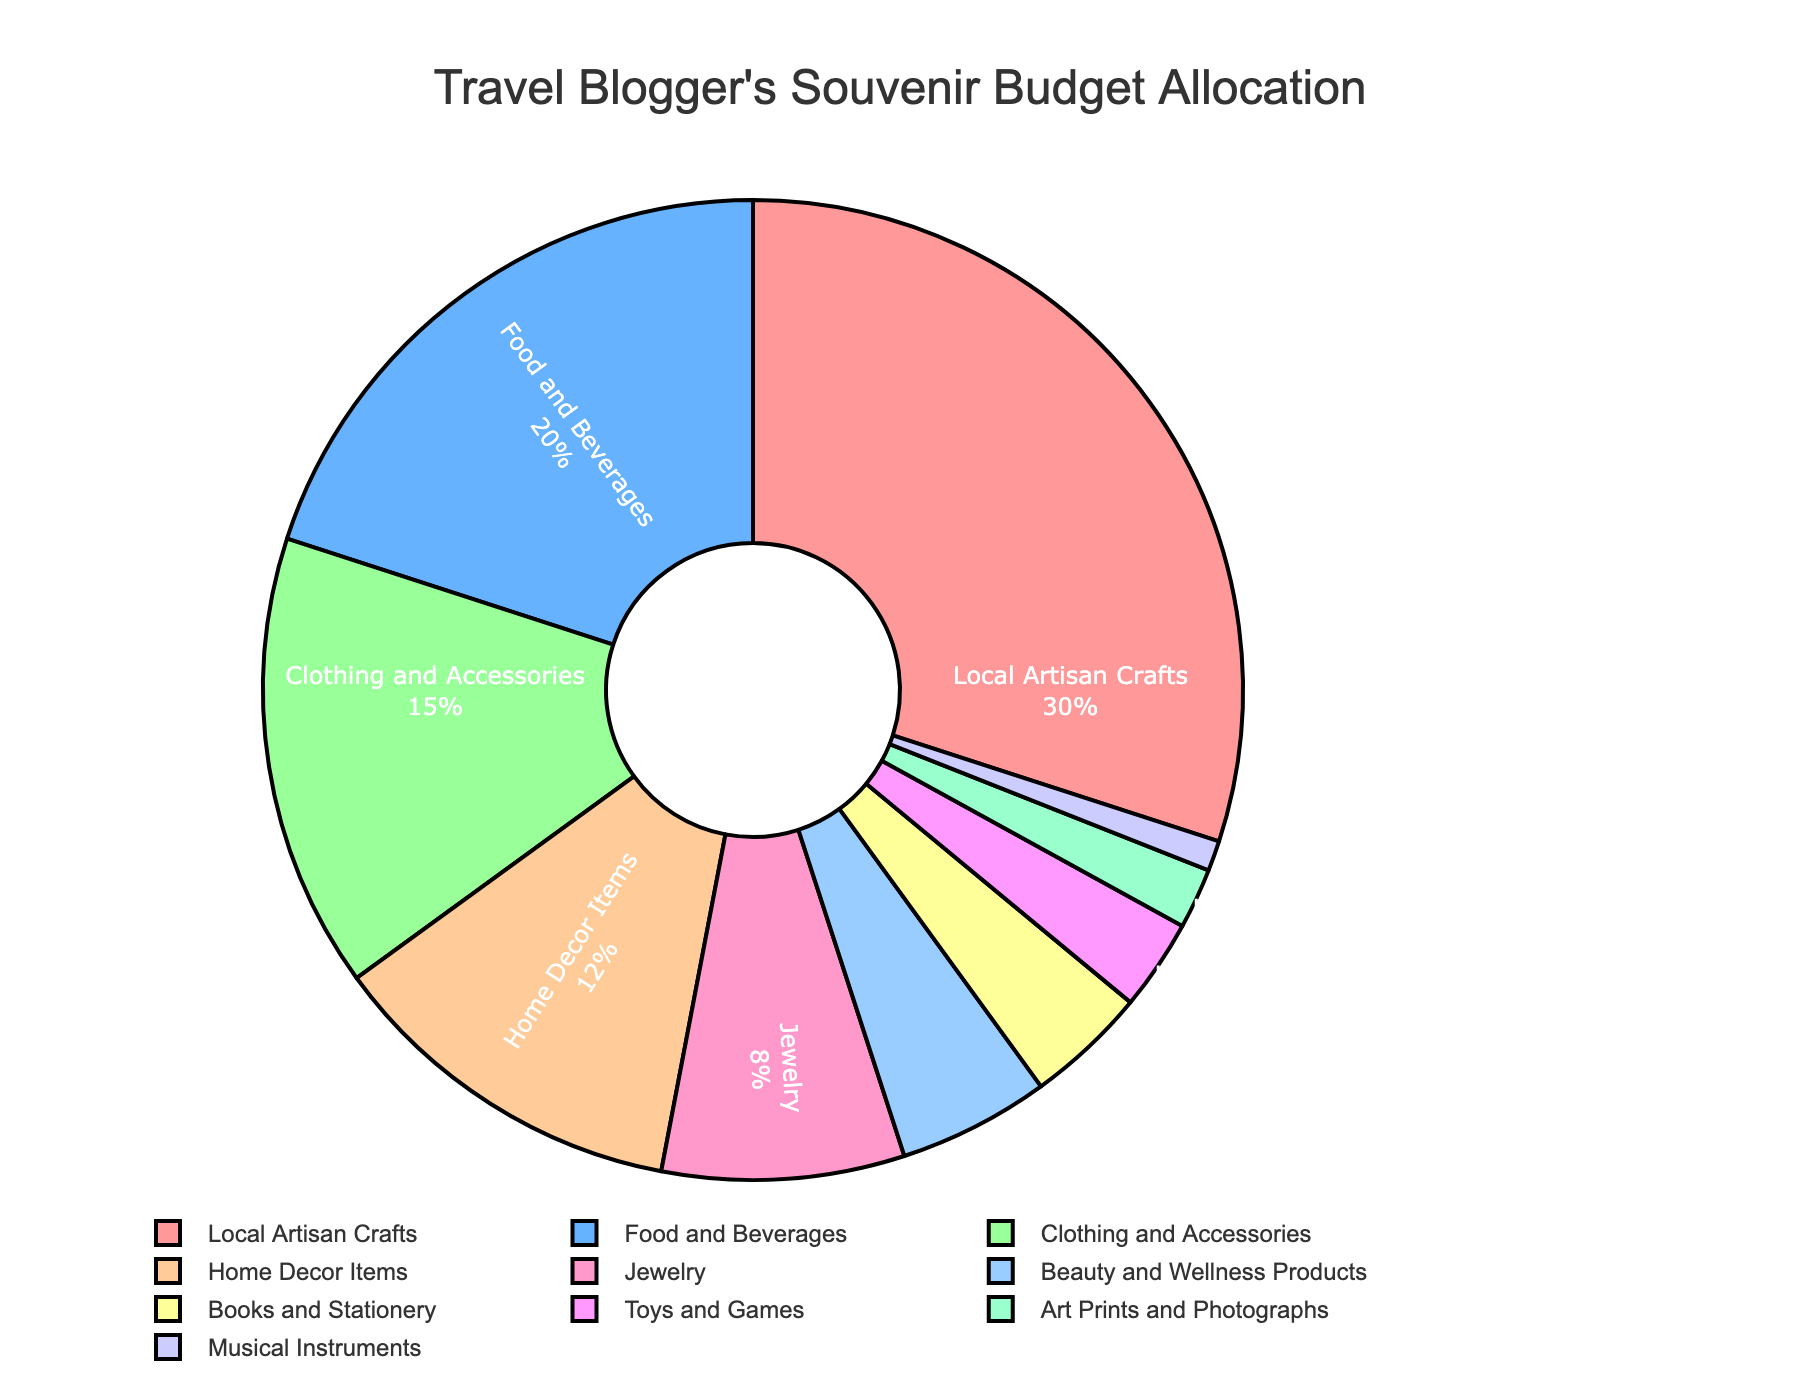what percentage of the budget is allocated to jewelry? Look at the segment labeled "Jewelry" on the pie chart. The percentage listed there represents the budget allocation for that category.
Answer: 8% what is the combined budget percentage for clothing and accessories and home decor items? Find the segments labeled "Clothing and Accessories" and "Home Decor Items." Add their percentages together: 15% + 12%.
Answer: 27% which category receives the smallest percentage of the budget, and what is that percentage? Find the smallest segment on the pie chart, which is labeled "Musical Instruments." The percentage listed there is the smallest.
Answer: Musical Instruments, 1% how much larger is the budget for local artisan crafts compared to beauty and wellness products? Look at the segments for "Local Artisan Crafts" and "Beauty and Wellness Products." Subtract the smaller percentage from the larger one: 30% - 5%.
Answer: 25% what is the total budget percentage for books and stationery combined with toys and games? Locate the segments labeled "Books and Stationery" and "Toys and Games." Add their percentages together: 4% + 3%.
Answer: 7% which category has a higher budget allocation: food and beverages or home decor items? Compare the segments for "Food and Beverages" and "Home Decor Items." The one with the higher percentage has a higher budget allocation.
Answer: Food and Beverages in which color is the biggest category represented? Identify the largest segment, which is "Local Artisan Crafts," and note its color in the pie chart.
Answer: Red (or specify the exact shade if different) what is the difference between the budget for food and beverages and the budget for clothing and accessories? Locate the segments for "Food and Beverages" and "Clothing and Accessories." Subtract the smaller percentage from the larger one: 20% - 15%.
Answer: 5% what is the sum of the budget percentages for all categories except the largest one? First, identify the largest category, "Local Artisan Crafts" (30%). Add together all other percentages: 100% - 30% = 70%.
Answer: 70% which categories collectively make up less than 10% of the budget? Identify the segments with percentages less than 10%. Sum their percentages to ensure they collectively make up less than 10%.
Answer: Musical Instruments, Art Prints and Photographs, Toys and Games, Books and Stationery 